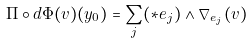Convert formula to latex. <formula><loc_0><loc_0><loc_500><loc_500>\Pi \circ d \Phi ( v ) ( y _ { 0 } ) = \sum _ { j } ( * e _ { j } ) \wedge \nabla _ { e _ { j } } ( v )</formula> 